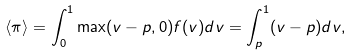Convert formula to latex. <formula><loc_0><loc_0><loc_500><loc_500>\langle \pi \rangle = \int _ { 0 } ^ { 1 } \max ( v - p , 0 ) f ( v ) d v = \int _ { p } ^ { 1 } ( v - p ) d v ,</formula> 